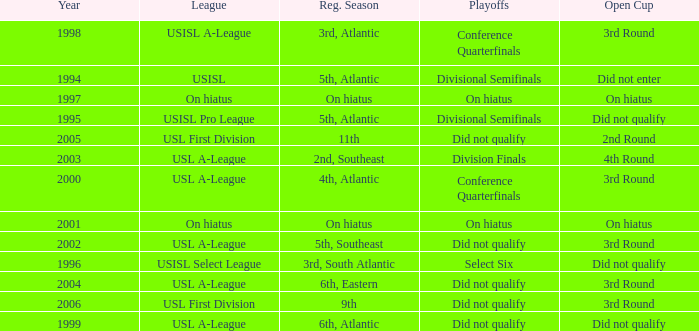In which year did the usisl pro league first start? 1995.0. 